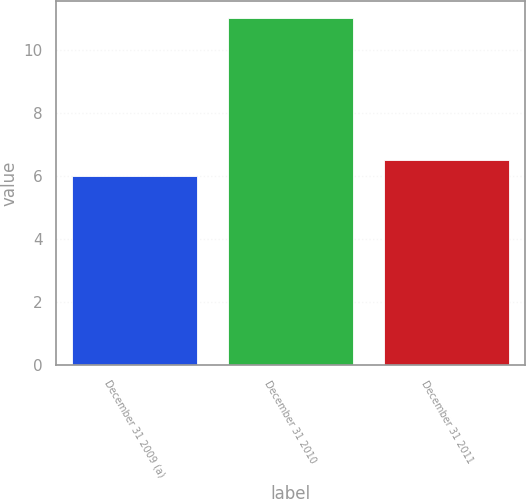<chart> <loc_0><loc_0><loc_500><loc_500><bar_chart><fcel>December 31 2009 (a)<fcel>December 31 2010<fcel>December 31 2011<nl><fcel>6<fcel>11<fcel>6.5<nl></chart> 